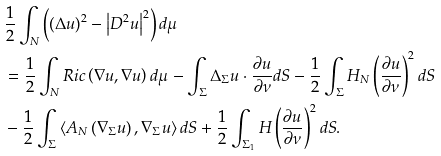<formula> <loc_0><loc_0><loc_500><loc_500>& \frac { 1 } { 2 } \int _ { N } \left ( \left ( \Delta u \right ) ^ { 2 } - \left | D ^ { 2 } u \right | ^ { 2 } \right ) d \mu \\ & = \frac { 1 } { 2 } \int _ { N } R i c \left ( \nabla u , \nabla u \right ) d \mu - \int _ { \Sigma } \Delta _ { \Sigma } u \cdot \frac { \partial u } { \partial \nu } d S - \frac { 1 } { 2 } \int _ { \Sigma } H _ { N } \left ( \frac { \partial u } { \partial \nu } \right ) ^ { 2 } d S \\ & - \frac { 1 } { 2 } \int _ { \Sigma } \left \langle A _ { N } \left ( \nabla _ { \Sigma } u \right ) , \nabla _ { \Sigma } u \right \rangle d S + \frac { 1 } { 2 } \int _ { \Sigma _ { 1 } } H \left ( \frac { \partial u } { \partial \nu } \right ) ^ { 2 } d S .</formula> 